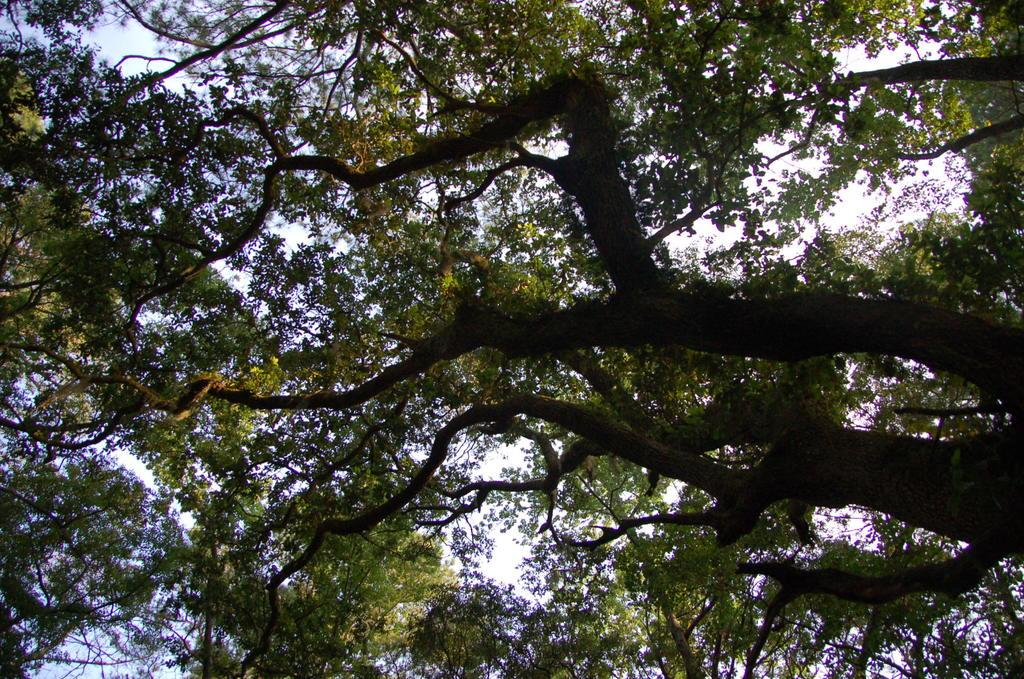What type of vegetation can be seen in the image? There are trees in the image. What part of the natural environment is visible in the image? The sky is visible in the background of the image. What type of fairies can be seen flying around the trees in the image? There are no fairies present in the image; it only features trees and the sky. What does the image smell like? Images do not have a sense of smell, so it is not possible to determine what the image might smell like. 